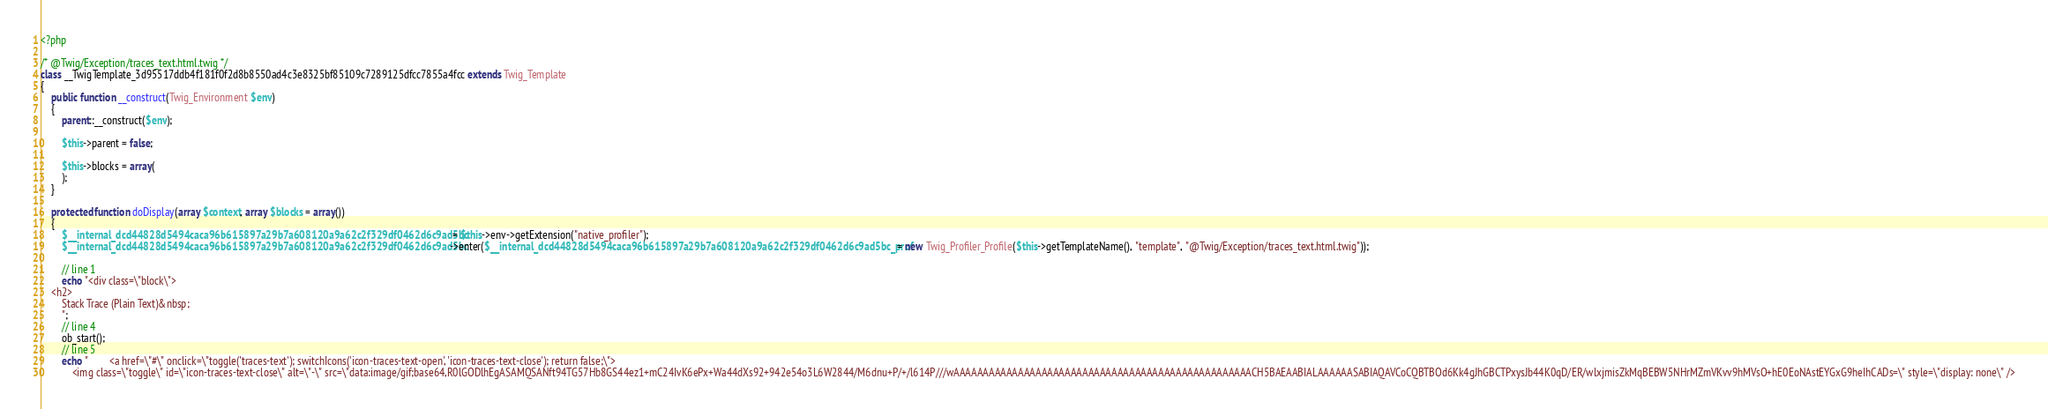<code> <loc_0><loc_0><loc_500><loc_500><_PHP_><?php

/* @Twig/Exception/traces_text.html.twig */
class __TwigTemplate_3d95517ddb4f181f0f2d8b8550ad4c3e8325bf85109c7289125dfcc7855a4fcc extends Twig_Template
{
    public function __construct(Twig_Environment $env)
    {
        parent::__construct($env);

        $this->parent = false;

        $this->blocks = array(
        );
    }

    protected function doDisplay(array $context, array $blocks = array())
    {
        $__internal_dcd44828d5494caca96b615897a29b7a608120a9a62c2f329df0462d6c9ad5bc = $this->env->getExtension("native_profiler");
        $__internal_dcd44828d5494caca96b615897a29b7a608120a9a62c2f329df0462d6c9ad5bc->enter($__internal_dcd44828d5494caca96b615897a29b7a608120a9a62c2f329df0462d6c9ad5bc_prof = new Twig_Profiler_Profile($this->getTemplateName(), "template", "@Twig/Exception/traces_text.html.twig"));

        // line 1
        echo "<div class=\"block\">
    <h2>
        Stack Trace (Plain Text)&nbsp;
        ";
        // line 4
        ob_start();
        // line 5
        echo "        <a href=\"#\" onclick=\"toggle('traces-text'); switchIcons('icon-traces-text-open', 'icon-traces-text-close'); return false;\">
            <img class=\"toggle\" id=\"icon-traces-text-close\" alt=\"-\" src=\"data:image/gif;base64,R0lGODlhEgASAMQSANft94TG57Hb8GS44ez1+mC24IvK6ePx+Wa44dXs92+942e54o3L6W2844/M6dnu+P/+/l614P///wAAAAAAAAAAAAAAAAAAAAAAAAAAAAAAAAAAAAAAAAAAAAAAAAAAACH5BAEAABIALAAAAAASABIAQAVCoCQBTBOd6Kk4gJhGBCTPxysJb44K0qD/ER/wlxjmisZkMqBEBW5NHrMZmVKvv9hMVsO+hE0EoNAstEYGxG9heIhCADs=\" style=\"display: none\" /></code> 